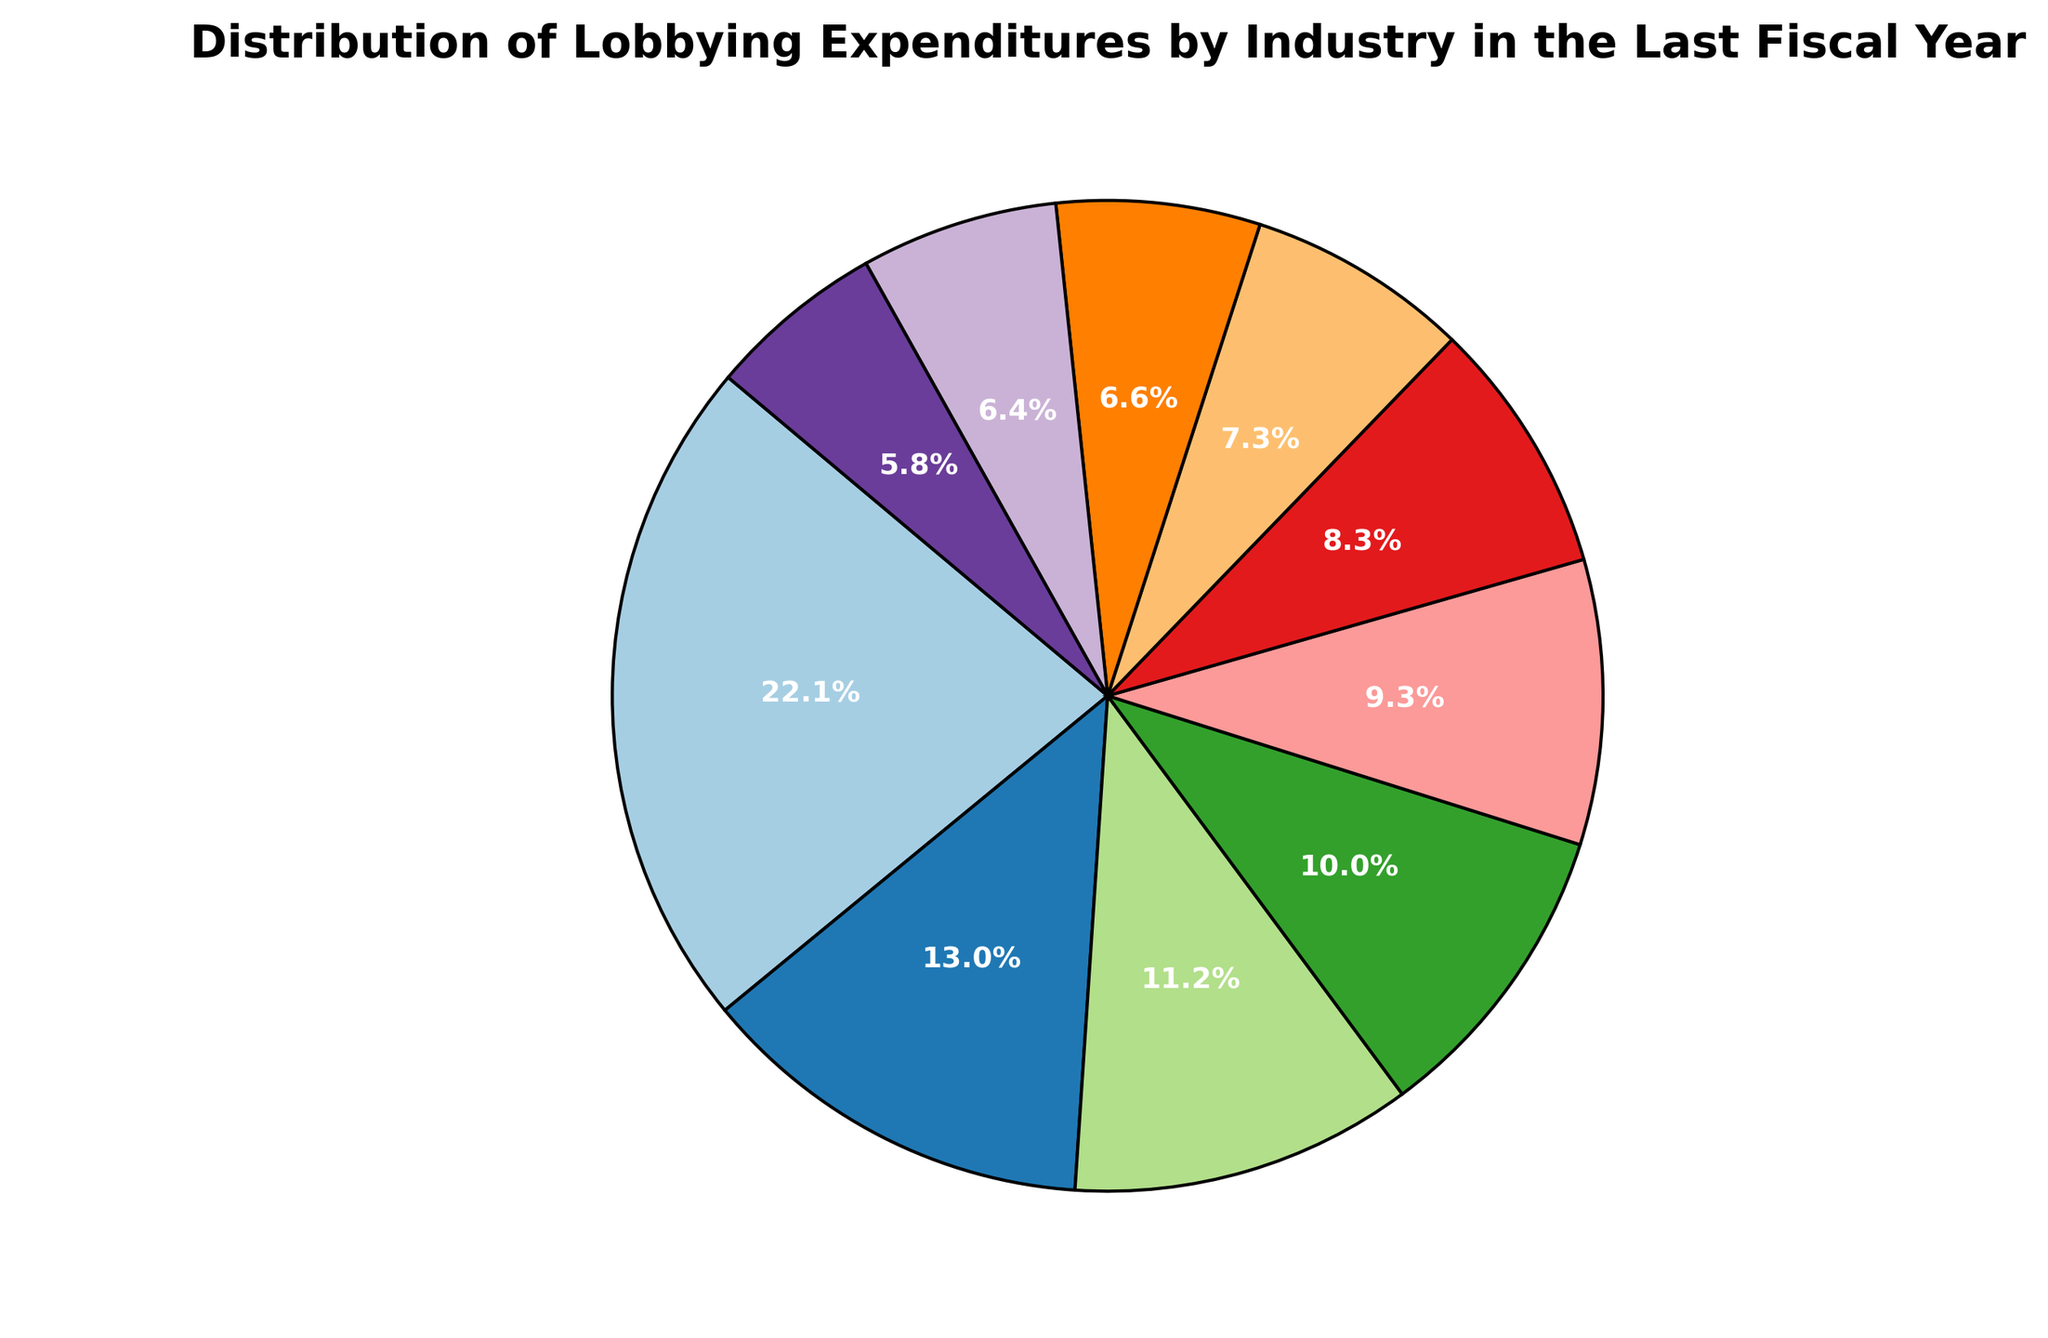Which industry had the highest lobbying expenditure in the last fiscal year? Look at the sector of the pie chart with the largest area or the largest label value for expenditure. Pharmaceuticals/Health Products had the highest expenditure of 306.2 million USD.
Answer: Pharmaceuticals/Health Products What percentage of the total lobbying expenditures was spent by the Oil & Gas industry? Find the Oil & Gas sector in the pie chart and read the percentage label shown on the slice. It shows 138.9 million USD, which is 10.6% of the total.
Answer: 10.6% How much more did the Pharmaceuticals/Health Products industry spend on lobbying compared to the Real Estate industry? The Pharmaceuticals/Health Products industry spent 306.2 million USD and the Real Estate industry spent 80.2 million USD. Subtract the latter from the former: 306.2 - 80.2 = 226 million USD.
Answer: 226 million USD Which two industries combined spent approximately the same as the Pharmaceuticals/Health Products industry? Identify two industry expenditures that sum close to 306.2 million USD. Here, Electronics/Manufacturing & Equipment (180.5) + Insurance (155.3) = 335.8 million USD, which is close.
Answer: Electronics/Manufacturing & Equipment and Insurance What is the average expenditure of the top 3 industries? Sum the top 3 expenditures (306.2 for Pharmaceuticals/Health Products, 180.5 for Electronics/Manufacturing & Equipment, 155.3 for Insurance) and divide by 3. (306.2 + 180.5 + 155.3) / 3 = 214 million USD.
Answer: 214 million USD Which industry spent more: Telecom Services or Electric Utilities, and by how much? Compare the expenditures: Telecom Services (115.6 million USD) and Electric Utilities (129.1 million USD). Subtract the smaller from the larger: 129.1 - 115.6 = 13.5 million USD. Electric Utilities spent 13.5 million more.
Answer: Electric Utilities, 13.5 million USD What fraction of the total expenditures was spent by the Education industry? Find the sector and label for Education to see its expenditure (92.3 million USD). Find the total expenditure by summing all sectors (total is 1387.2 million USD). Divide Education's expenditure by the total: 92.3 / 1387.2 ≈ 0.0665, which is approximately 6.65%.
Answer: 6.65% What is the combined percentage of lobbying expenditures for the Business Associations and Commercial Banks industries? Find and add the percentage labels for Business Associations and Commercial Banks. Business Associations show 7.3% and Commercial Banks show 6.4%. Adding: 7.3% + 6.4% = 13.7%.
Answer: 13.7% How does the expenditure of the Insurance industry compare with that of the Oil & Gas industry? Compare the expenditures: Insurance is 155.3 million USD and Oil & Gas is 138.9 million USD. Insurance spends more.
Answer: Insurance spends more What are the colors of the slices representing the Pharmaceuticals/Health Products and the Oil & Gas industries, respectively? Visually inspect the pie chart for the colors of the mentioned slices. Pharmaceuticals/Health Products is often at the beginning of the colormap scheme, and Oil & Gas is found later. Pharmaceuticals/Health Products might be a bold color like blue or red, and Oil & Gas could be a contrasting color like yellow or green.
Answer: (Color details based on chart specifics) 